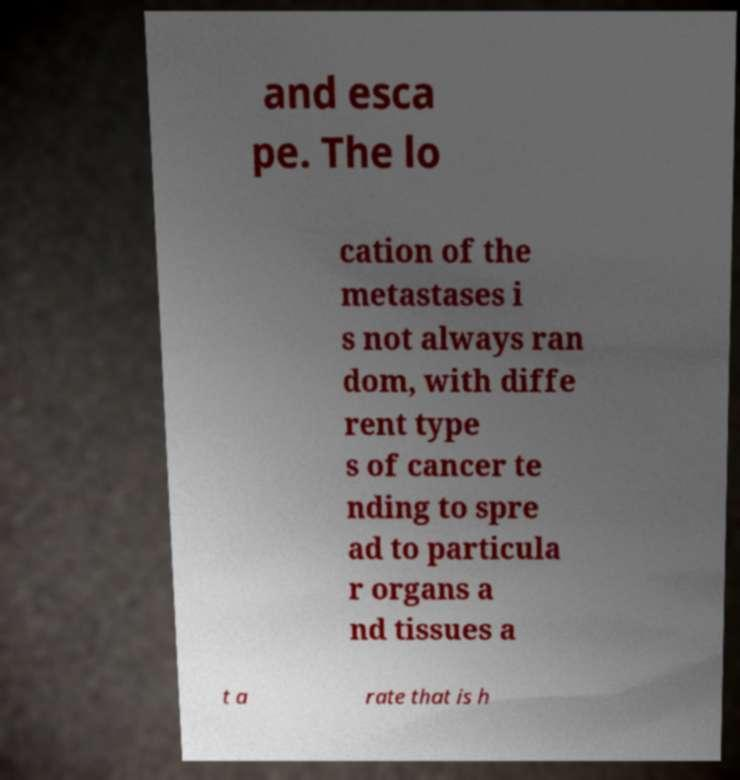Can you accurately transcribe the text from the provided image for me? and esca pe. The lo cation of the metastases i s not always ran dom, with diffe rent type s of cancer te nding to spre ad to particula r organs a nd tissues a t a rate that is h 